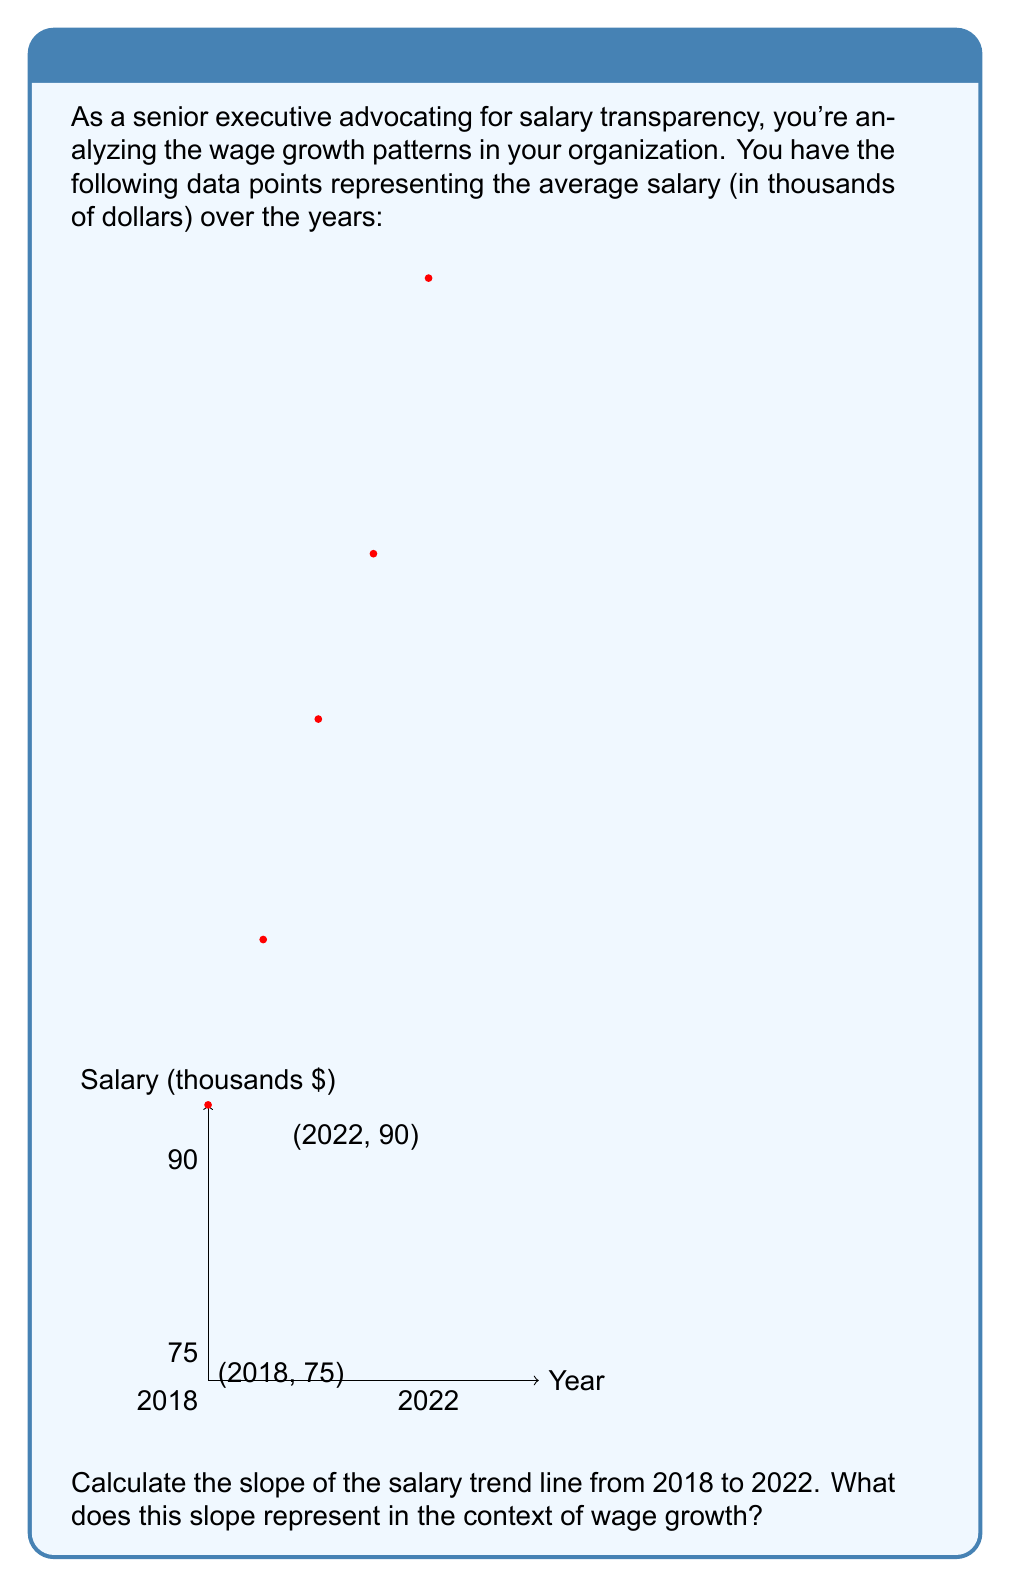Can you answer this question? To calculate the slope of the salary trend line, we'll use the slope formula:

$$ \text{slope} = \frac{y_2 - y_1}{x_2 - x_1} $$

Where $(x_1, y_1)$ is the starting point and $(x_2, y_2)$ is the ending point.

Step 1: Identify the coordinates
- Starting point (2018): $(x_1, y_1) = (2018, 75)$
- Ending point (2022): $(x_2, y_2) = (2022, 90)$

Step 2: Plug the values into the slope formula
$$ \text{slope} = \frac{90 - 75}{2022 - 2018} = \frac{15}{4} = 3.75 $$

Step 3: Interpret the result
The slope of 3.75 represents the average yearly increase in salary (in thousands of dollars) over the four-year period. This means that, on average, salaries increased by $3,750 per year from 2018 to 2022.

In the context of wage growth, this slope indicates a positive trend in salaries, with an average annual growth rate of $3,750. This information is crucial for assessing the organization's commitment to competitive pay and can be used to compare with industry standards or cost of living increases.
Answer: 3.75 (thousand dollars per year) 